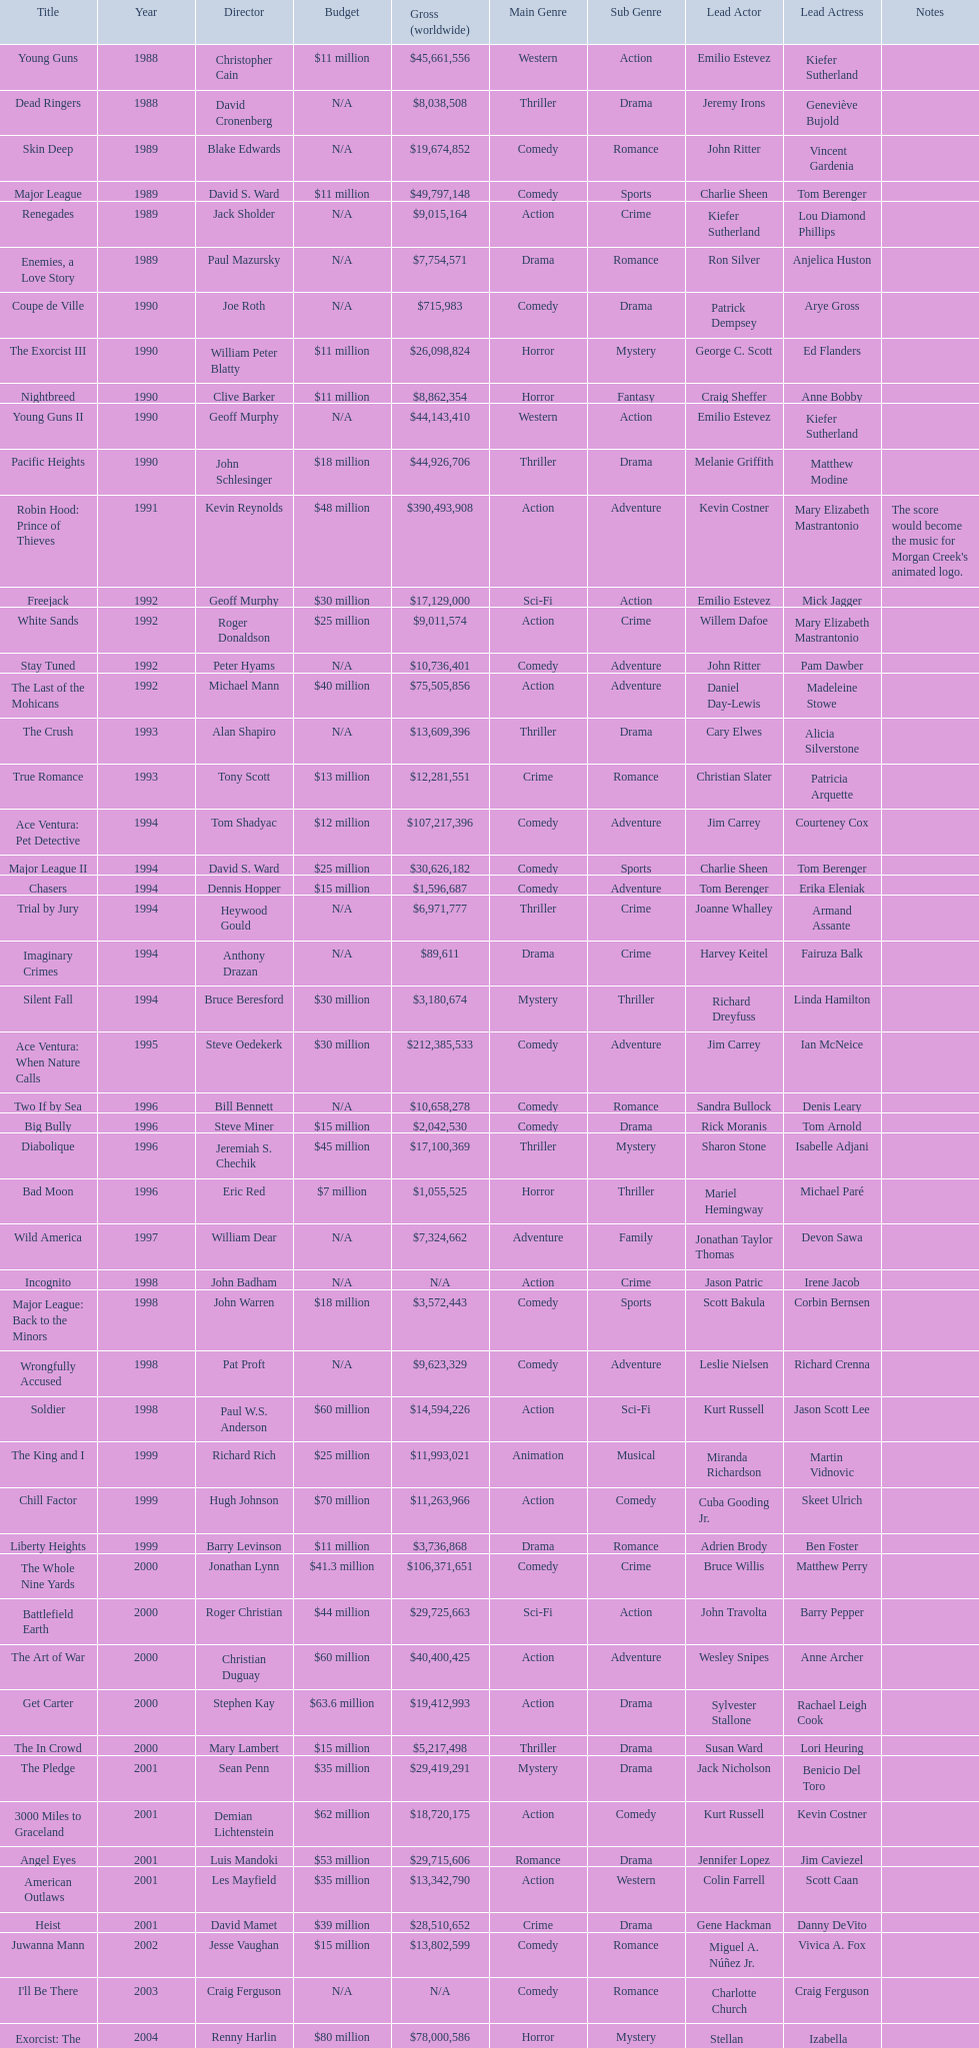What is the number of films directed by david s. ward? 2. 